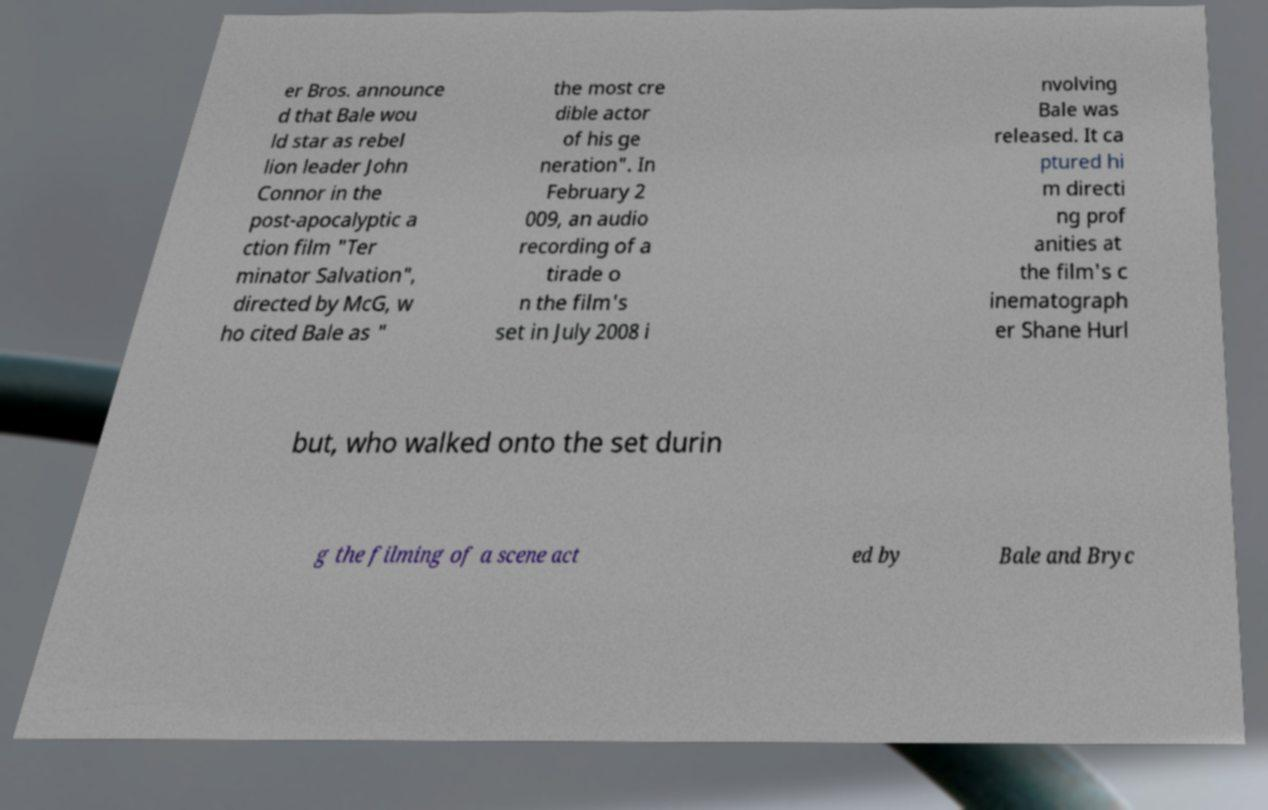Please identify and transcribe the text found in this image. er Bros. announce d that Bale wou ld star as rebel lion leader John Connor in the post-apocalyptic a ction film "Ter minator Salvation", directed by McG, w ho cited Bale as " the most cre dible actor of his ge neration". In February 2 009, an audio recording of a tirade o n the film's set in July 2008 i nvolving Bale was released. It ca ptured hi m directi ng prof anities at the film's c inematograph er Shane Hurl but, who walked onto the set durin g the filming of a scene act ed by Bale and Bryc 